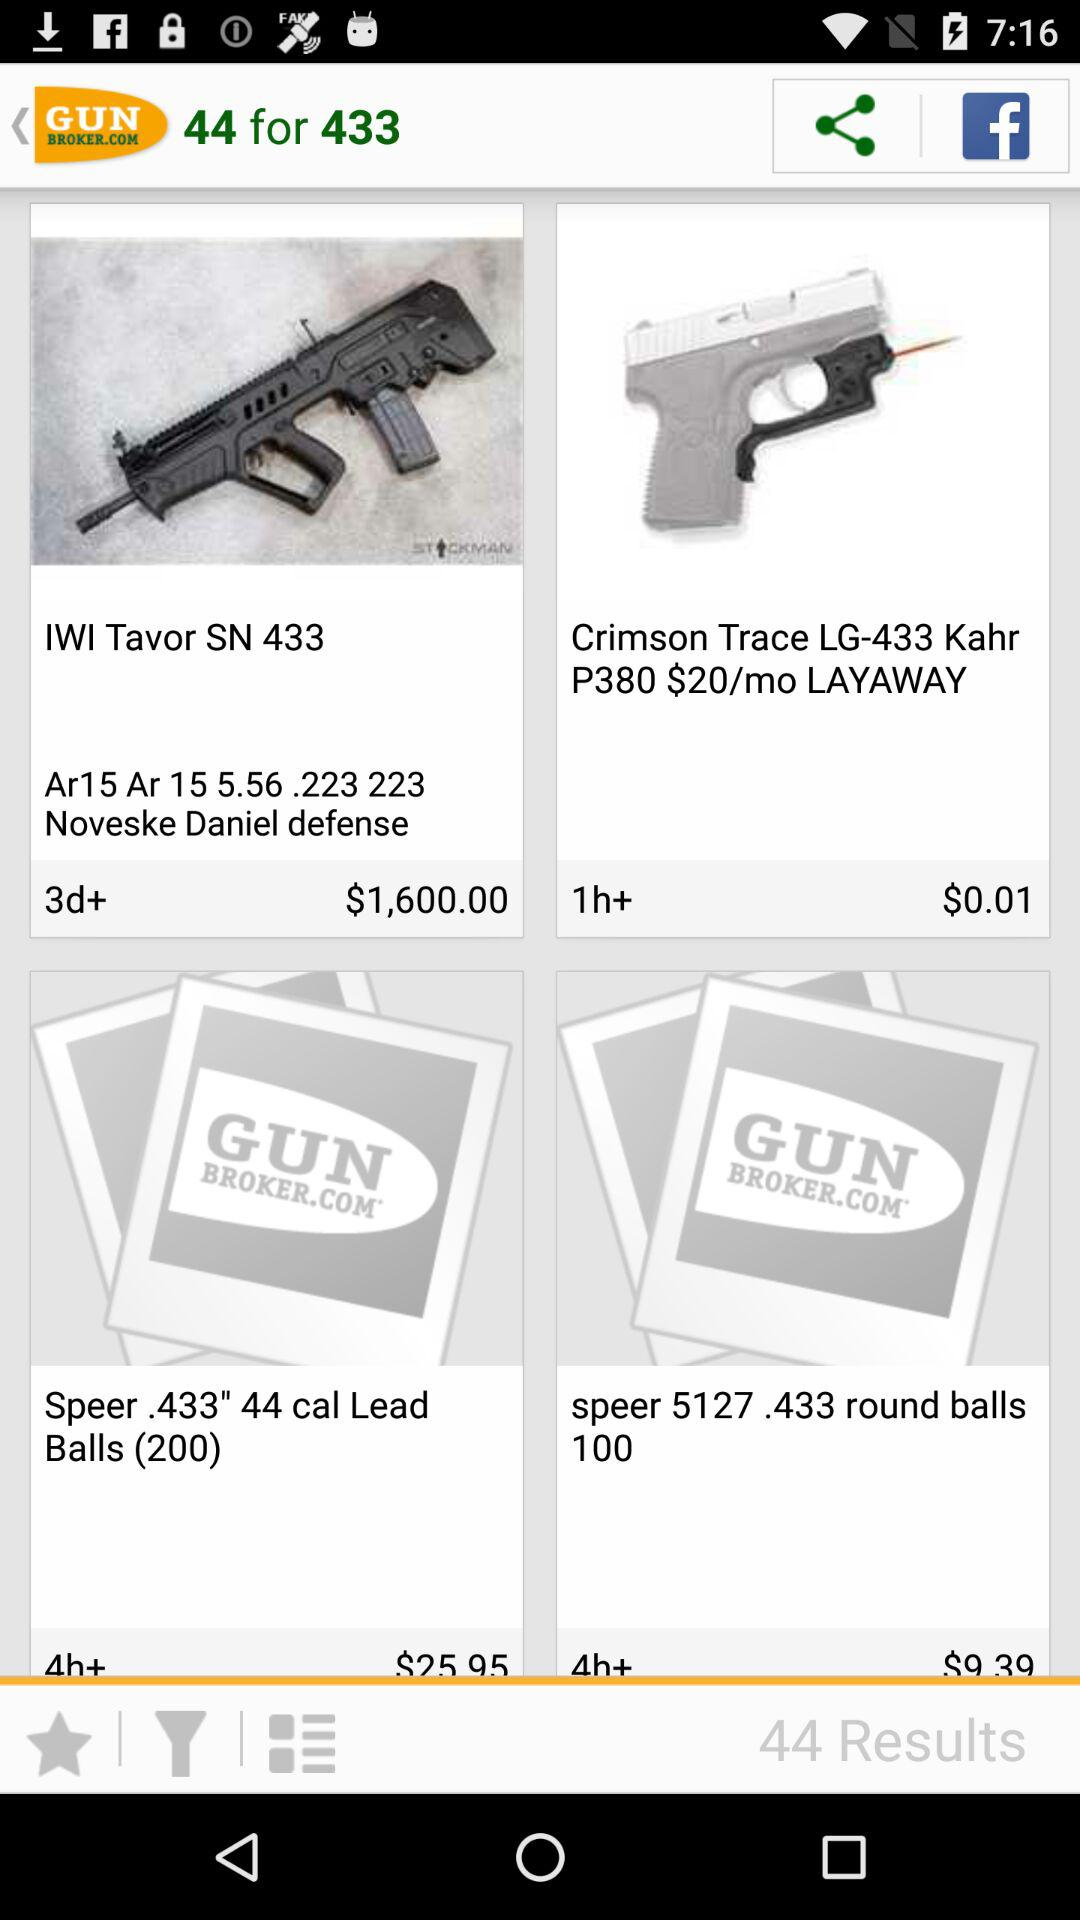What is the name of the application? The name of the application is "GUN BROKER.COM". 